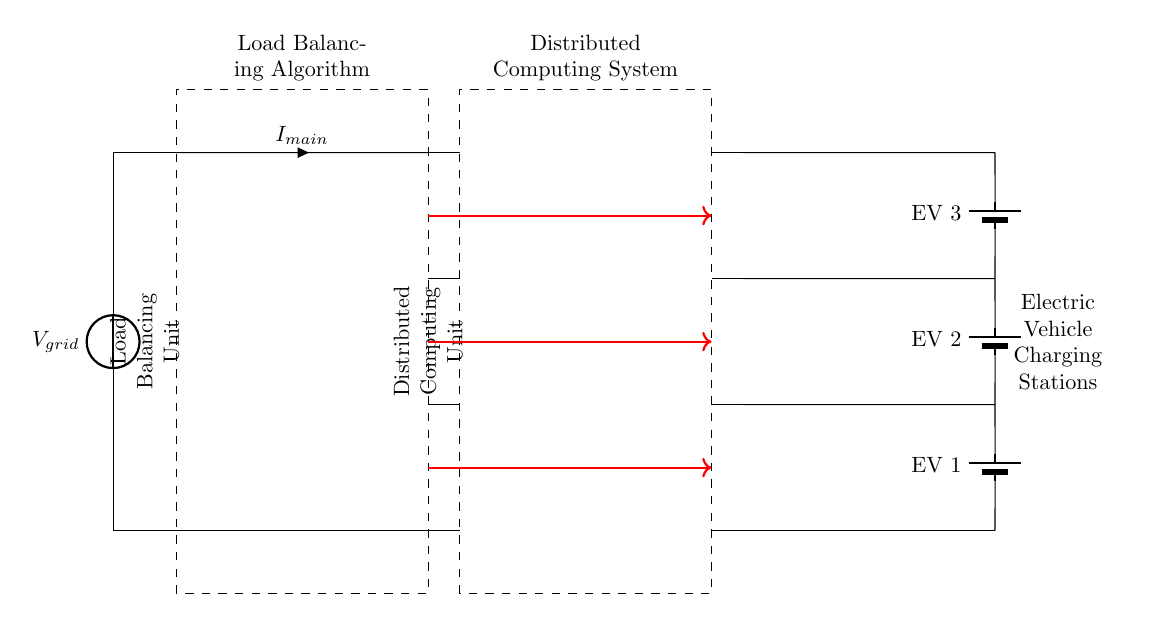What is the voltage source in this circuit? The voltage source is labeled as V sub grid, indicating that it is the source of electrical power for the entire circuit.
Answer: V grid How many electric vehicle charging stations are present in the diagram? The diagram shows three distinct electric vehicle charging stations, each labeled as EV 1, EV 2, and EV 3.
Answer: 3 What is the purpose of the load balancing unit? The load balancing unit, as indicated by its label in the circuit, is responsible for managing the distribution of power among the connected electric vehicles to prevent overload and ensure efficient charging.
Answer: Load management What type of unit is indicated to handle distributed computing? The rectangular box labeled as Distributed Computing Unit suggests that its role is to manage and process data for the electric vehicle charging station's operations, allowing for real-time monitoring and control.
Answer: Distributed Computing Unit Which component connects the main power supply to the load balancing unit? The line connecting the voltage source V sub grid to the load balancing unit signifies that it carries the main current, indicating the flow of electricity into the load balancing unit.
Answer: I main 